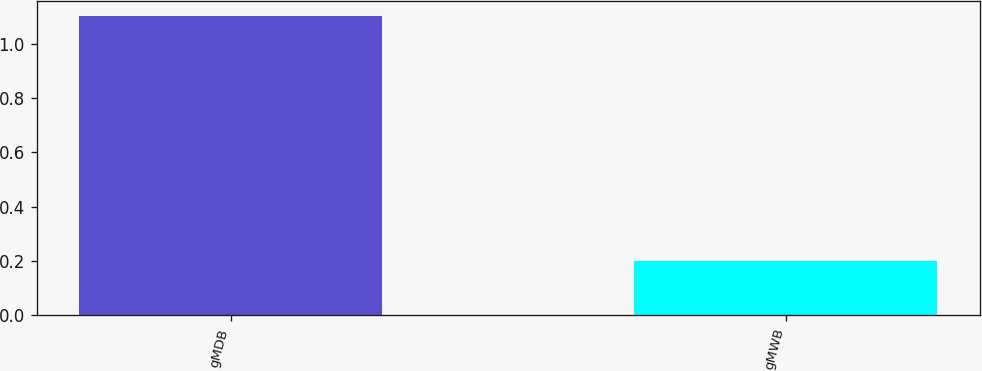Convert chart. <chart><loc_0><loc_0><loc_500><loc_500><bar_chart><fcel>gMDB<fcel>gMWB<nl><fcel>1.1<fcel>0.2<nl></chart> 